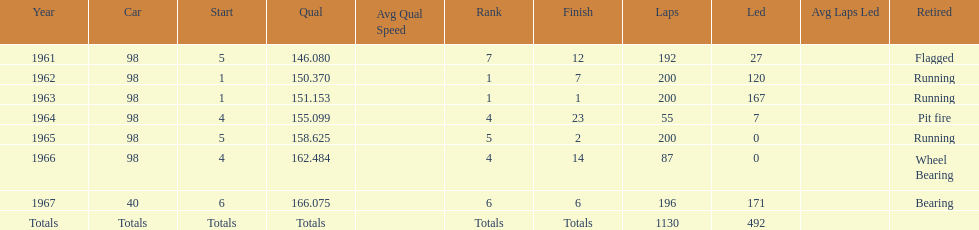Previous to 1965, when did jones have a number 5 start at the indy 500? 1961. 